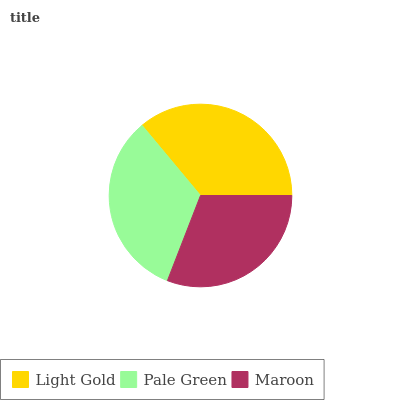Is Maroon the minimum?
Answer yes or no. Yes. Is Light Gold the maximum?
Answer yes or no. Yes. Is Pale Green the minimum?
Answer yes or no. No. Is Pale Green the maximum?
Answer yes or no. No. Is Light Gold greater than Pale Green?
Answer yes or no. Yes. Is Pale Green less than Light Gold?
Answer yes or no. Yes. Is Pale Green greater than Light Gold?
Answer yes or no. No. Is Light Gold less than Pale Green?
Answer yes or no. No. Is Pale Green the high median?
Answer yes or no. Yes. Is Pale Green the low median?
Answer yes or no. Yes. Is Maroon the high median?
Answer yes or no. No. Is Light Gold the low median?
Answer yes or no. No. 